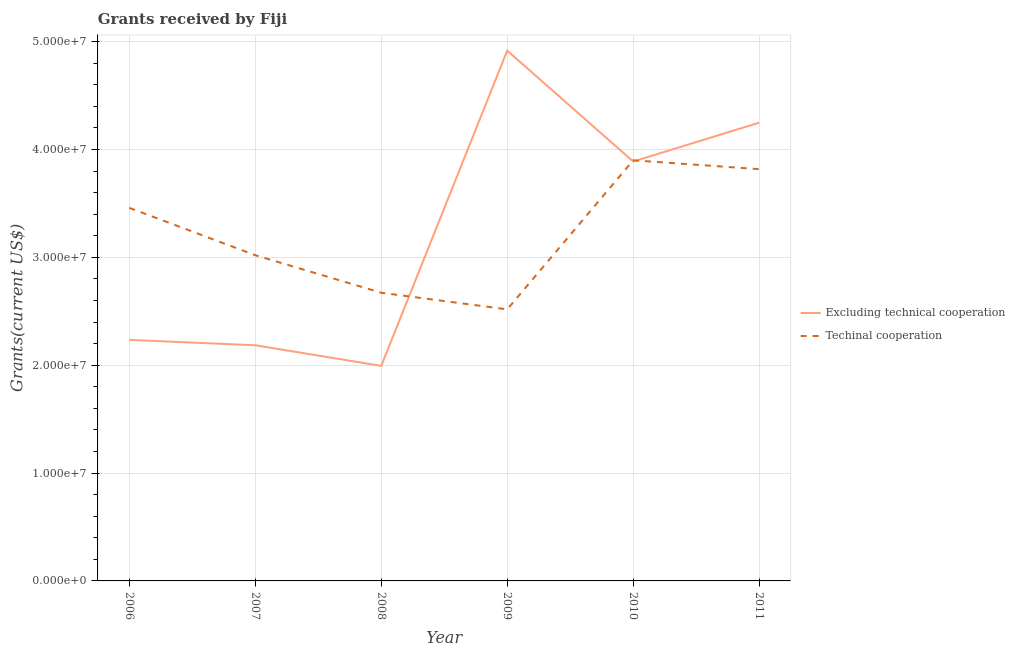How many different coloured lines are there?
Provide a short and direct response. 2. What is the amount of grants received(excluding technical cooperation) in 2007?
Offer a very short reply. 2.18e+07. Across all years, what is the maximum amount of grants received(including technical cooperation)?
Keep it short and to the point. 3.90e+07. Across all years, what is the minimum amount of grants received(including technical cooperation)?
Ensure brevity in your answer.  2.52e+07. In which year was the amount of grants received(excluding technical cooperation) minimum?
Ensure brevity in your answer.  2008. What is the total amount of grants received(including technical cooperation) in the graph?
Offer a terse response. 1.94e+08. What is the difference between the amount of grants received(including technical cooperation) in 2006 and that in 2007?
Offer a terse response. 4.39e+06. What is the difference between the amount of grants received(including technical cooperation) in 2007 and the amount of grants received(excluding technical cooperation) in 2008?
Provide a short and direct response. 1.03e+07. What is the average amount of grants received(including technical cooperation) per year?
Offer a terse response. 3.23e+07. In the year 2010, what is the difference between the amount of grants received(excluding technical cooperation) and amount of grants received(including technical cooperation)?
Provide a succinct answer. -1.10e+05. In how many years, is the amount of grants received(including technical cooperation) greater than 6000000 US$?
Offer a terse response. 6. What is the ratio of the amount of grants received(including technical cooperation) in 2008 to that in 2011?
Your answer should be very brief. 0.7. Is the amount of grants received(including technical cooperation) in 2006 less than that in 2007?
Offer a very short reply. No. Is the difference between the amount of grants received(including technical cooperation) in 2006 and 2007 greater than the difference between the amount of grants received(excluding technical cooperation) in 2006 and 2007?
Your answer should be compact. Yes. What is the difference between the highest and the second highest amount of grants received(excluding technical cooperation)?
Offer a terse response. 6.68e+06. What is the difference between the highest and the lowest amount of grants received(including technical cooperation)?
Provide a succinct answer. 1.38e+07. Does the amount of grants received(including technical cooperation) monotonically increase over the years?
Ensure brevity in your answer.  No. Is the amount of grants received(excluding technical cooperation) strictly greater than the amount of grants received(including technical cooperation) over the years?
Give a very brief answer. No. Is the amount of grants received(excluding technical cooperation) strictly less than the amount of grants received(including technical cooperation) over the years?
Give a very brief answer. No. How many years are there in the graph?
Provide a succinct answer. 6. Are the values on the major ticks of Y-axis written in scientific E-notation?
Offer a very short reply. Yes. Does the graph contain any zero values?
Your response must be concise. No. Does the graph contain grids?
Make the answer very short. Yes. Where does the legend appear in the graph?
Provide a short and direct response. Center right. What is the title of the graph?
Your answer should be compact. Grants received by Fiji. What is the label or title of the X-axis?
Give a very brief answer. Year. What is the label or title of the Y-axis?
Offer a terse response. Grants(current US$). What is the Grants(current US$) in Excluding technical cooperation in 2006?
Offer a terse response. 2.24e+07. What is the Grants(current US$) in Techinal cooperation in 2006?
Offer a very short reply. 3.46e+07. What is the Grants(current US$) in Excluding technical cooperation in 2007?
Give a very brief answer. 2.18e+07. What is the Grants(current US$) in Techinal cooperation in 2007?
Keep it short and to the point. 3.02e+07. What is the Grants(current US$) of Excluding technical cooperation in 2008?
Offer a very short reply. 1.99e+07. What is the Grants(current US$) in Techinal cooperation in 2008?
Provide a succinct answer. 2.67e+07. What is the Grants(current US$) of Excluding technical cooperation in 2009?
Offer a very short reply. 4.92e+07. What is the Grants(current US$) of Techinal cooperation in 2009?
Provide a succinct answer. 2.52e+07. What is the Grants(current US$) in Excluding technical cooperation in 2010?
Offer a terse response. 3.89e+07. What is the Grants(current US$) of Techinal cooperation in 2010?
Keep it short and to the point. 3.90e+07. What is the Grants(current US$) in Excluding technical cooperation in 2011?
Your answer should be very brief. 4.25e+07. What is the Grants(current US$) of Techinal cooperation in 2011?
Your answer should be very brief. 3.82e+07. Across all years, what is the maximum Grants(current US$) in Excluding technical cooperation?
Provide a short and direct response. 4.92e+07. Across all years, what is the maximum Grants(current US$) in Techinal cooperation?
Offer a very short reply. 3.90e+07. Across all years, what is the minimum Grants(current US$) in Excluding technical cooperation?
Offer a very short reply. 1.99e+07. Across all years, what is the minimum Grants(current US$) of Techinal cooperation?
Offer a terse response. 2.52e+07. What is the total Grants(current US$) of Excluding technical cooperation in the graph?
Your response must be concise. 1.95e+08. What is the total Grants(current US$) of Techinal cooperation in the graph?
Offer a very short reply. 1.94e+08. What is the difference between the Grants(current US$) of Techinal cooperation in 2006 and that in 2007?
Provide a short and direct response. 4.39e+06. What is the difference between the Grants(current US$) in Excluding technical cooperation in 2006 and that in 2008?
Your response must be concise. 2.41e+06. What is the difference between the Grants(current US$) in Techinal cooperation in 2006 and that in 2008?
Offer a very short reply. 7.87e+06. What is the difference between the Grants(current US$) in Excluding technical cooperation in 2006 and that in 2009?
Provide a succinct answer. -2.68e+07. What is the difference between the Grants(current US$) of Techinal cooperation in 2006 and that in 2009?
Provide a short and direct response. 9.41e+06. What is the difference between the Grants(current US$) in Excluding technical cooperation in 2006 and that in 2010?
Keep it short and to the point. -1.65e+07. What is the difference between the Grants(current US$) of Techinal cooperation in 2006 and that in 2010?
Your answer should be very brief. -4.41e+06. What is the difference between the Grants(current US$) in Excluding technical cooperation in 2006 and that in 2011?
Make the answer very short. -2.01e+07. What is the difference between the Grants(current US$) of Techinal cooperation in 2006 and that in 2011?
Make the answer very short. -3.59e+06. What is the difference between the Grants(current US$) of Excluding technical cooperation in 2007 and that in 2008?
Your answer should be very brief. 1.91e+06. What is the difference between the Grants(current US$) of Techinal cooperation in 2007 and that in 2008?
Your answer should be compact. 3.48e+06. What is the difference between the Grants(current US$) in Excluding technical cooperation in 2007 and that in 2009?
Give a very brief answer. -2.73e+07. What is the difference between the Grants(current US$) of Techinal cooperation in 2007 and that in 2009?
Your response must be concise. 5.02e+06. What is the difference between the Grants(current US$) in Excluding technical cooperation in 2007 and that in 2010?
Offer a very short reply. -1.70e+07. What is the difference between the Grants(current US$) in Techinal cooperation in 2007 and that in 2010?
Make the answer very short. -8.80e+06. What is the difference between the Grants(current US$) of Excluding technical cooperation in 2007 and that in 2011?
Provide a succinct answer. -2.06e+07. What is the difference between the Grants(current US$) in Techinal cooperation in 2007 and that in 2011?
Make the answer very short. -7.98e+06. What is the difference between the Grants(current US$) in Excluding technical cooperation in 2008 and that in 2009?
Give a very brief answer. -2.92e+07. What is the difference between the Grants(current US$) in Techinal cooperation in 2008 and that in 2009?
Offer a terse response. 1.54e+06. What is the difference between the Grants(current US$) of Excluding technical cooperation in 2008 and that in 2010?
Offer a very short reply. -1.90e+07. What is the difference between the Grants(current US$) of Techinal cooperation in 2008 and that in 2010?
Your response must be concise. -1.23e+07. What is the difference between the Grants(current US$) of Excluding technical cooperation in 2008 and that in 2011?
Offer a very short reply. -2.26e+07. What is the difference between the Grants(current US$) in Techinal cooperation in 2008 and that in 2011?
Make the answer very short. -1.15e+07. What is the difference between the Grants(current US$) in Excluding technical cooperation in 2009 and that in 2010?
Offer a terse response. 1.03e+07. What is the difference between the Grants(current US$) of Techinal cooperation in 2009 and that in 2010?
Offer a very short reply. -1.38e+07. What is the difference between the Grants(current US$) of Excluding technical cooperation in 2009 and that in 2011?
Your answer should be compact. 6.68e+06. What is the difference between the Grants(current US$) of Techinal cooperation in 2009 and that in 2011?
Ensure brevity in your answer.  -1.30e+07. What is the difference between the Grants(current US$) in Excluding technical cooperation in 2010 and that in 2011?
Give a very brief answer. -3.60e+06. What is the difference between the Grants(current US$) in Techinal cooperation in 2010 and that in 2011?
Ensure brevity in your answer.  8.20e+05. What is the difference between the Grants(current US$) in Excluding technical cooperation in 2006 and the Grants(current US$) in Techinal cooperation in 2007?
Offer a very short reply. -7.85e+06. What is the difference between the Grants(current US$) in Excluding technical cooperation in 2006 and the Grants(current US$) in Techinal cooperation in 2008?
Make the answer very short. -4.37e+06. What is the difference between the Grants(current US$) of Excluding technical cooperation in 2006 and the Grants(current US$) of Techinal cooperation in 2009?
Offer a terse response. -2.83e+06. What is the difference between the Grants(current US$) in Excluding technical cooperation in 2006 and the Grants(current US$) in Techinal cooperation in 2010?
Your response must be concise. -1.66e+07. What is the difference between the Grants(current US$) in Excluding technical cooperation in 2006 and the Grants(current US$) in Techinal cooperation in 2011?
Your response must be concise. -1.58e+07. What is the difference between the Grants(current US$) in Excluding technical cooperation in 2007 and the Grants(current US$) in Techinal cooperation in 2008?
Give a very brief answer. -4.87e+06. What is the difference between the Grants(current US$) of Excluding technical cooperation in 2007 and the Grants(current US$) of Techinal cooperation in 2009?
Keep it short and to the point. -3.33e+06. What is the difference between the Grants(current US$) of Excluding technical cooperation in 2007 and the Grants(current US$) of Techinal cooperation in 2010?
Provide a short and direct response. -1.72e+07. What is the difference between the Grants(current US$) of Excluding technical cooperation in 2007 and the Grants(current US$) of Techinal cooperation in 2011?
Your answer should be compact. -1.63e+07. What is the difference between the Grants(current US$) in Excluding technical cooperation in 2008 and the Grants(current US$) in Techinal cooperation in 2009?
Your answer should be very brief. -5.24e+06. What is the difference between the Grants(current US$) in Excluding technical cooperation in 2008 and the Grants(current US$) in Techinal cooperation in 2010?
Give a very brief answer. -1.91e+07. What is the difference between the Grants(current US$) of Excluding technical cooperation in 2008 and the Grants(current US$) of Techinal cooperation in 2011?
Ensure brevity in your answer.  -1.82e+07. What is the difference between the Grants(current US$) in Excluding technical cooperation in 2009 and the Grants(current US$) in Techinal cooperation in 2010?
Your answer should be very brief. 1.02e+07. What is the difference between the Grants(current US$) of Excluding technical cooperation in 2009 and the Grants(current US$) of Techinal cooperation in 2011?
Provide a short and direct response. 1.10e+07. What is the difference between the Grants(current US$) in Excluding technical cooperation in 2010 and the Grants(current US$) in Techinal cooperation in 2011?
Your answer should be compact. 7.10e+05. What is the average Grants(current US$) in Excluding technical cooperation per year?
Offer a very short reply. 3.24e+07. What is the average Grants(current US$) in Techinal cooperation per year?
Provide a succinct answer. 3.23e+07. In the year 2006, what is the difference between the Grants(current US$) in Excluding technical cooperation and Grants(current US$) in Techinal cooperation?
Give a very brief answer. -1.22e+07. In the year 2007, what is the difference between the Grants(current US$) in Excluding technical cooperation and Grants(current US$) in Techinal cooperation?
Offer a terse response. -8.35e+06. In the year 2008, what is the difference between the Grants(current US$) of Excluding technical cooperation and Grants(current US$) of Techinal cooperation?
Offer a very short reply. -6.78e+06. In the year 2009, what is the difference between the Grants(current US$) of Excluding technical cooperation and Grants(current US$) of Techinal cooperation?
Make the answer very short. 2.40e+07. In the year 2010, what is the difference between the Grants(current US$) in Excluding technical cooperation and Grants(current US$) in Techinal cooperation?
Make the answer very short. -1.10e+05. In the year 2011, what is the difference between the Grants(current US$) in Excluding technical cooperation and Grants(current US$) in Techinal cooperation?
Your answer should be compact. 4.31e+06. What is the ratio of the Grants(current US$) in Excluding technical cooperation in 2006 to that in 2007?
Provide a succinct answer. 1.02. What is the ratio of the Grants(current US$) of Techinal cooperation in 2006 to that in 2007?
Give a very brief answer. 1.15. What is the ratio of the Grants(current US$) of Excluding technical cooperation in 2006 to that in 2008?
Your response must be concise. 1.12. What is the ratio of the Grants(current US$) in Techinal cooperation in 2006 to that in 2008?
Keep it short and to the point. 1.29. What is the ratio of the Grants(current US$) of Excluding technical cooperation in 2006 to that in 2009?
Your response must be concise. 0.45. What is the ratio of the Grants(current US$) in Techinal cooperation in 2006 to that in 2009?
Ensure brevity in your answer.  1.37. What is the ratio of the Grants(current US$) of Excluding technical cooperation in 2006 to that in 2010?
Your response must be concise. 0.57. What is the ratio of the Grants(current US$) of Techinal cooperation in 2006 to that in 2010?
Provide a short and direct response. 0.89. What is the ratio of the Grants(current US$) in Excluding technical cooperation in 2006 to that in 2011?
Make the answer very short. 0.53. What is the ratio of the Grants(current US$) of Techinal cooperation in 2006 to that in 2011?
Keep it short and to the point. 0.91. What is the ratio of the Grants(current US$) in Excluding technical cooperation in 2007 to that in 2008?
Provide a succinct answer. 1.1. What is the ratio of the Grants(current US$) of Techinal cooperation in 2007 to that in 2008?
Provide a short and direct response. 1.13. What is the ratio of the Grants(current US$) in Excluding technical cooperation in 2007 to that in 2009?
Offer a terse response. 0.44. What is the ratio of the Grants(current US$) of Techinal cooperation in 2007 to that in 2009?
Your response must be concise. 1.2. What is the ratio of the Grants(current US$) of Excluding technical cooperation in 2007 to that in 2010?
Your answer should be very brief. 0.56. What is the ratio of the Grants(current US$) of Techinal cooperation in 2007 to that in 2010?
Give a very brief answer. 0.77. What is the ratio of the Grants(current US$) of Excluding technical cooperation in 2007 to that in 2011?
Your answer should be compact. 0.51. What is the ratio of the Grants(current US$) in Techinal cooperation in 2007 to that in 2011?
Your answer should be compact. 0.79. What is the ratio of the Grants(current US$) of Excluding technical cooperation in 2008 to that in 2009?
Your response must be concise. 0.41. What is the ratio of the Grants(current US$) in Techinal cooperation in 2008 to that in 2009?
Provide a succinct answer. 1.06. What is the ratio of the Grants(current US$) in Excluding technical cooperation in 2008 to that in 2010?
Provide a short and direct response. 0.51. What is the ratio of the Grants(current US$) in Techinal cooperation in 2008 to that in 2010?
Offer a very short reply. 0.69. What is the ratio of the Grants(current US$) in Excluding technical cooperation in 2008 to that in 2011?
Make the answer very short. 0.47. What is the ratio of the Grants(current US$) in Techinal cooperation in 2008 to that in 2011?
Keep it short and to the point. 0.7. What is the ratio of the Grants(current US$) in Excluding technical cooperation in 2009 to that in 2010?
Offer a terse response. 1.26. What is the ratio of the Grants(current US$) in Techinal cooperation in 2009 to that in 2010?
Provide a short and direct response. 0.65. What is the ratio of the Grants(current US$) of Excluding technical cooperation in 2009 to that in 2011?
Your answer should be compact. 1.16. What is the ratio of the Grants(current US$) in Techinal cooperation in 2009 to that in 2011?
Ensure brevity in your answer.  0.66. What is the ratio of the Grants(current US$) in Excluding technical cooperation in 2010 to that in 2011?
Make the answer very short. 0.92. What is the ratio of the Grants(current US$) of Techinal cooperation in 2010 to that in 2011?
Keep it short and to the point. 1.02. What is the difference between the highest and the second highest Grants(current US$) of Excluding technical cooperation?
Your response must be concise. 6.68e+06. What is the difference between the highest and the second highest Grants(current US$) in Techinal cooperation?
Provide a short and direct response. 8.20e+05. What is the difference between the highest and the lowest Grants(current US$) in Excluding technical cooperation?
Offer a very short reply. 2.92e+07. What is the difference between the highest and the lowest Grants(current US$) of Techinal cooperation?
Your response must be concise. 1.38e+07. 